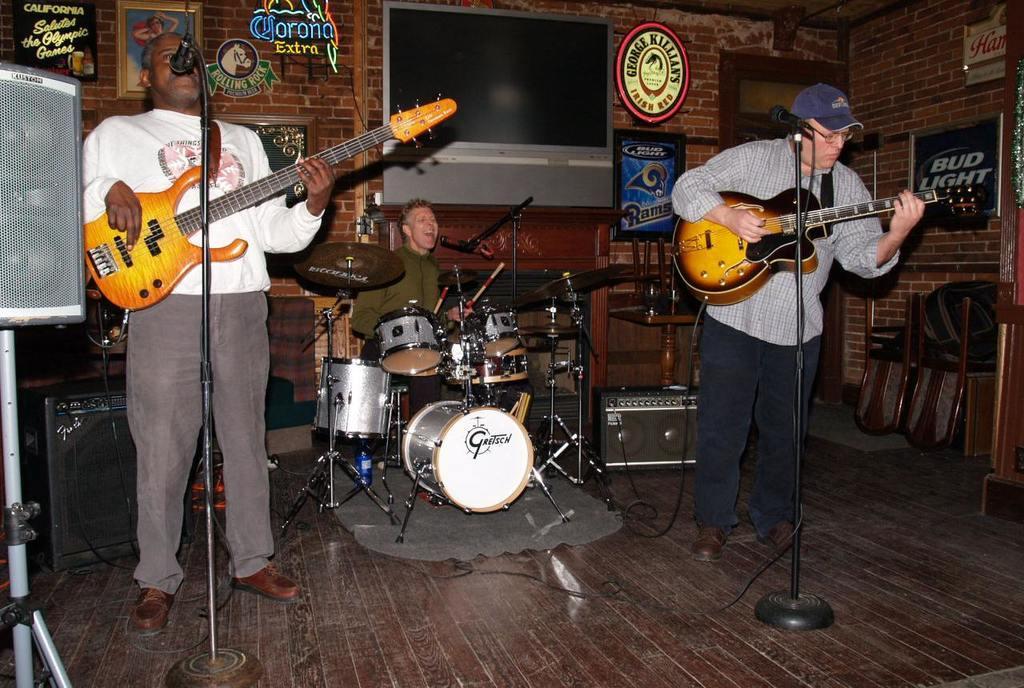How would you summarize this image in a sentence or two? In this picture we can see two persons are standing in front of mike. They are playing guitar. On the background we can see a man who is playing drums and he is singing on the mike. Here we can see a screen and this is wall. And there is a frame. 